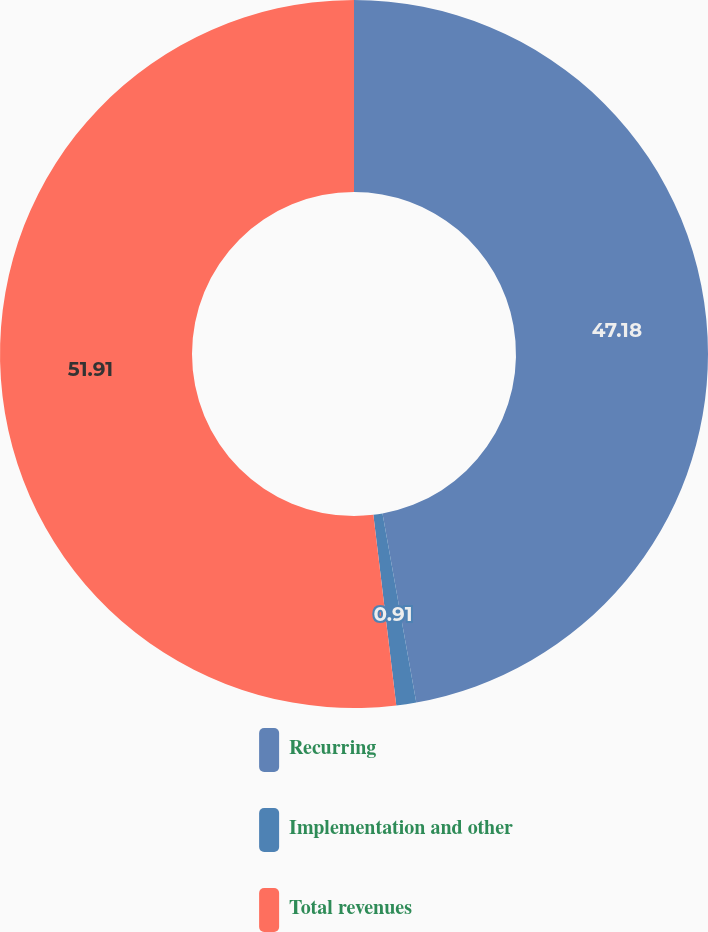<chart> <loc_0><loc_0><loc_500><loc_500><pie_chart><fcel>Recurring<fcel>Implementation and other<fcel>Total revenues<nl><fcel>47.18%<fcel>0.91%<fcel>51.9%<nl></chart> 